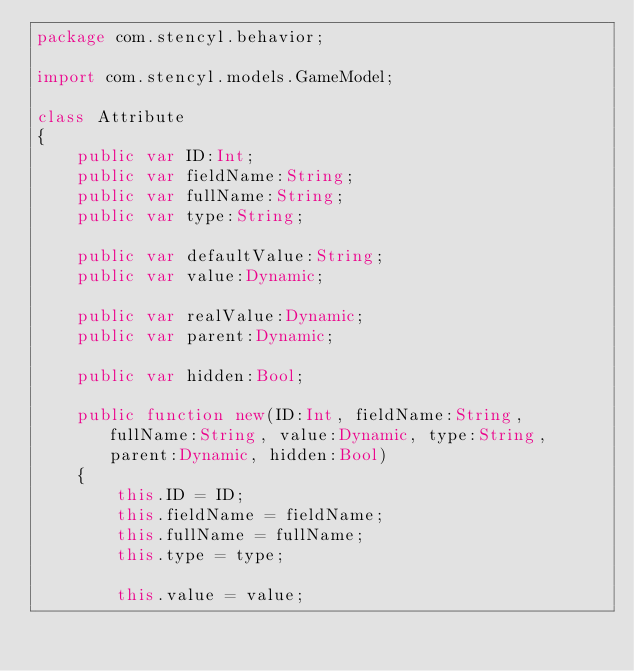Convert code to text. <code><loc_0><loc_0><loc_500><loc_500><_Haxe_>package com.stencyl.behavior;

import com.stencyl.models.GameModel;

class Attribute 
{	
	public var ID:Int;
	public var fieldName:String;
	public var fullName:String;
	public var type:String;
	
	public var defaultValue:String;
	public var value:Dynamic;
	
	public var realValue:Dynamic;
	public var parent:Dynamic;

	public var hidden:Bool;
	
	public function new(ID:Int, fieldName:String, fullName:String, value:Dynamic, type:String, parent:Dynamic, hidden:Bool)
	{
		this.ID = ID;
		this.fieldName = fieldName;
		this.fullName = fullName;
		this.type = type;

		this.value = value;</code> 